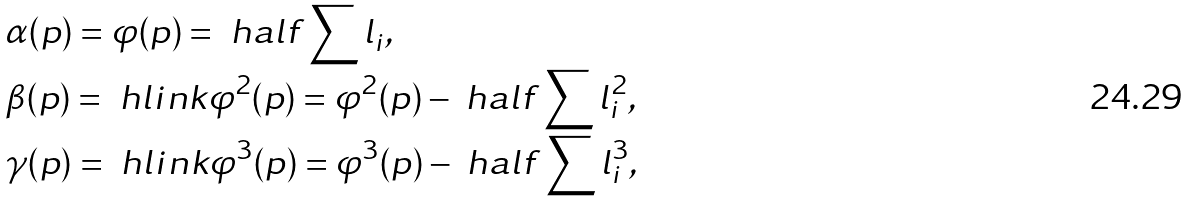<formula> <loc_0><loc_0><loc_500><loc_500>& \alpha ( p ) = \varphi ( p ) = \ h a l f \sum l _ { i } , \\ & \beta ( p ) = \ h l i n k \varphi ^ { 2 } ( p ) = \varphi ^ { 2 } ( p ) - \ h a l f \sum l ^ { 2 } _ { i } , \\ & \gamma ( p ) = \ h l i n k \varphi ^ { 3 } ( p ) = \varphi ^ { 3 } ( p ) - \ h a l f \sum l ^ { 3 } _ { i } ,</formula> 